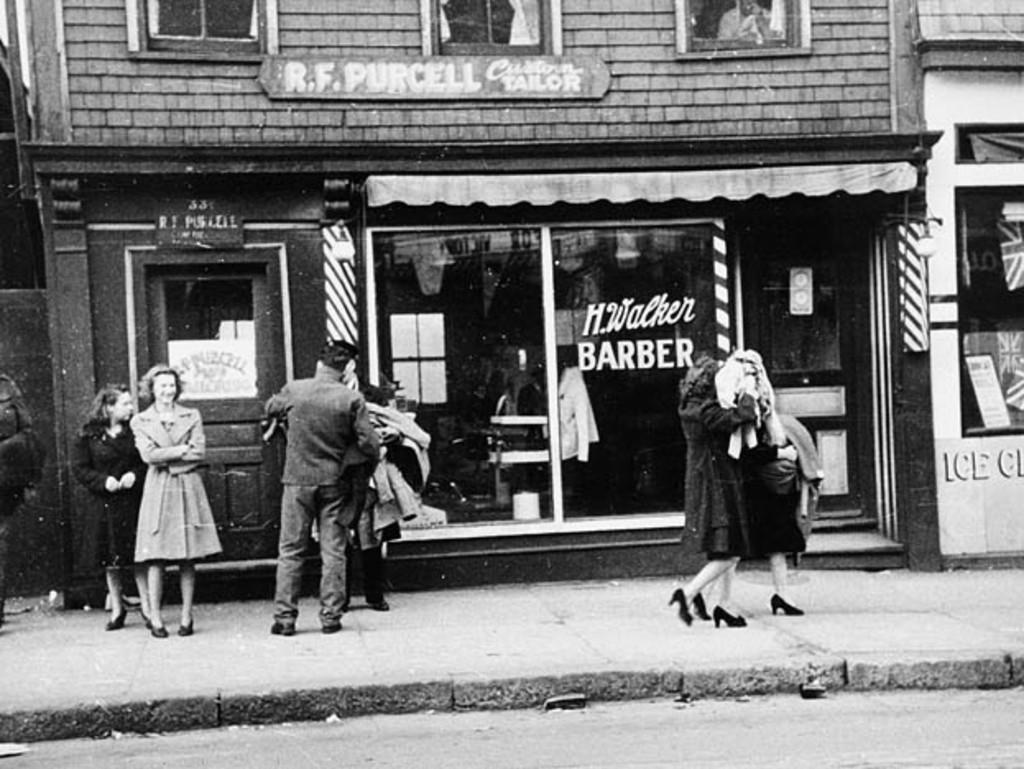How would you summarize this image in a sentence or two? Black and white pictures. In-front of this building there are people. Here we can see windows, boards and door. 